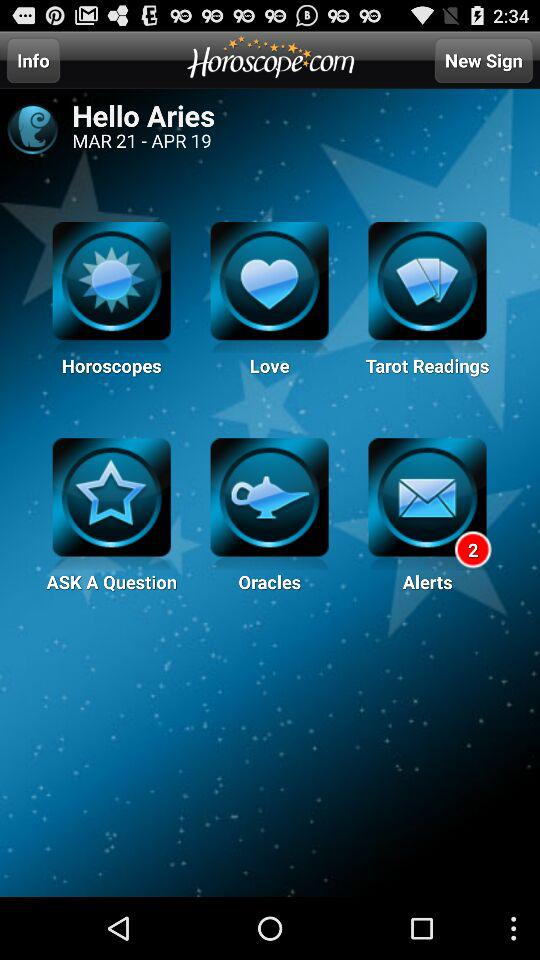What is the app name? The app name is "Horoscope.com". 